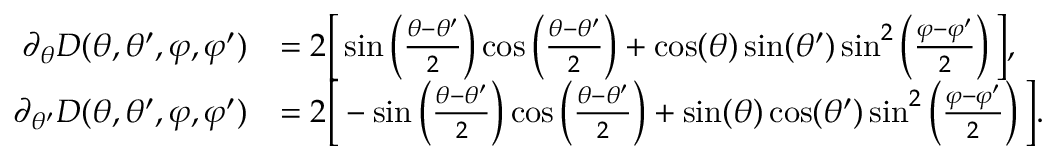<formula> <loc_0><loc_0><loc_500><loc_500>\begin{array} { r l } { \partial _ { \theta } D ( \theta , \theta ^ { \prime } , \varphi , \varphi ^ { \prime } ) } & { = 2 \left [ \sin \left ( \frac { \theta - \theta ^ { \prime } } { 2 } \right ) \cos \left ( \frac { \theta - \theta ^ { \prime } } { 2 } \right ) + \cos ( \theta ) \sin ( \theta ^ { \prime } ) \sin ^ { 2 } \left ( \frac { \varphi - \varphi ^ { \prime } } { 2 } \right ) \right ] , } \\ { \partial _ { \theta ^ { \prime } } D ( \theta , \theta ^ { \prime } , \varphi , \varphi ^ { \prime } ) } & { = 2 \left [ - \sin \left ( \frac { \theta - \theta ^ { \prime } } { 2 } \right ) \cos \left ( \frac { \theta - \theta ^ { \prime } } { 2 } \right ) + \sin ( \theta ) \cos ( \theta ^ { \prime } ) \sin ^ { 2 } \left ( \frac { \varphi - \varphi ^ { \prime } } { 2 } \right ) \right ] . } \end{array}</formula> 